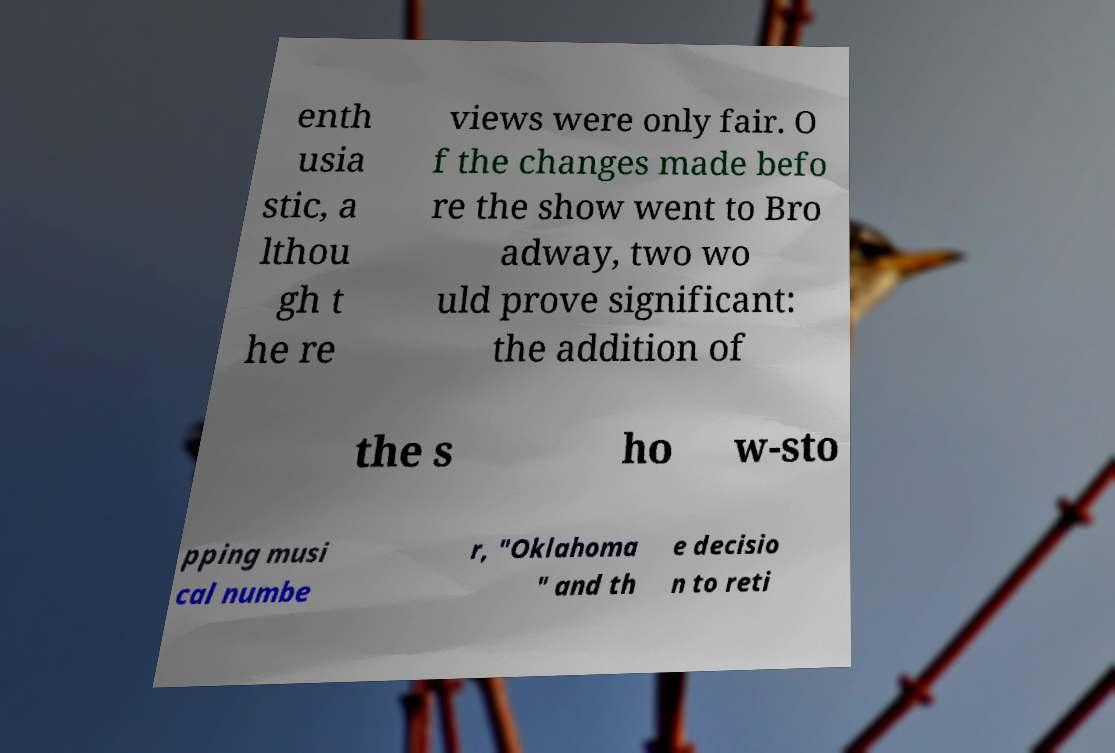There's text embedded in this image that I need extracted. Can you transcribe it verbatim? enth usia stic, a lthou gh t he re views were only fair. O f the changes made befo re the show went to Bro adway, two wo uld prove significant: the addition of the s ho w-sto pping musi cal numbe r, "Oklahoma " and th e decisio n to reti 